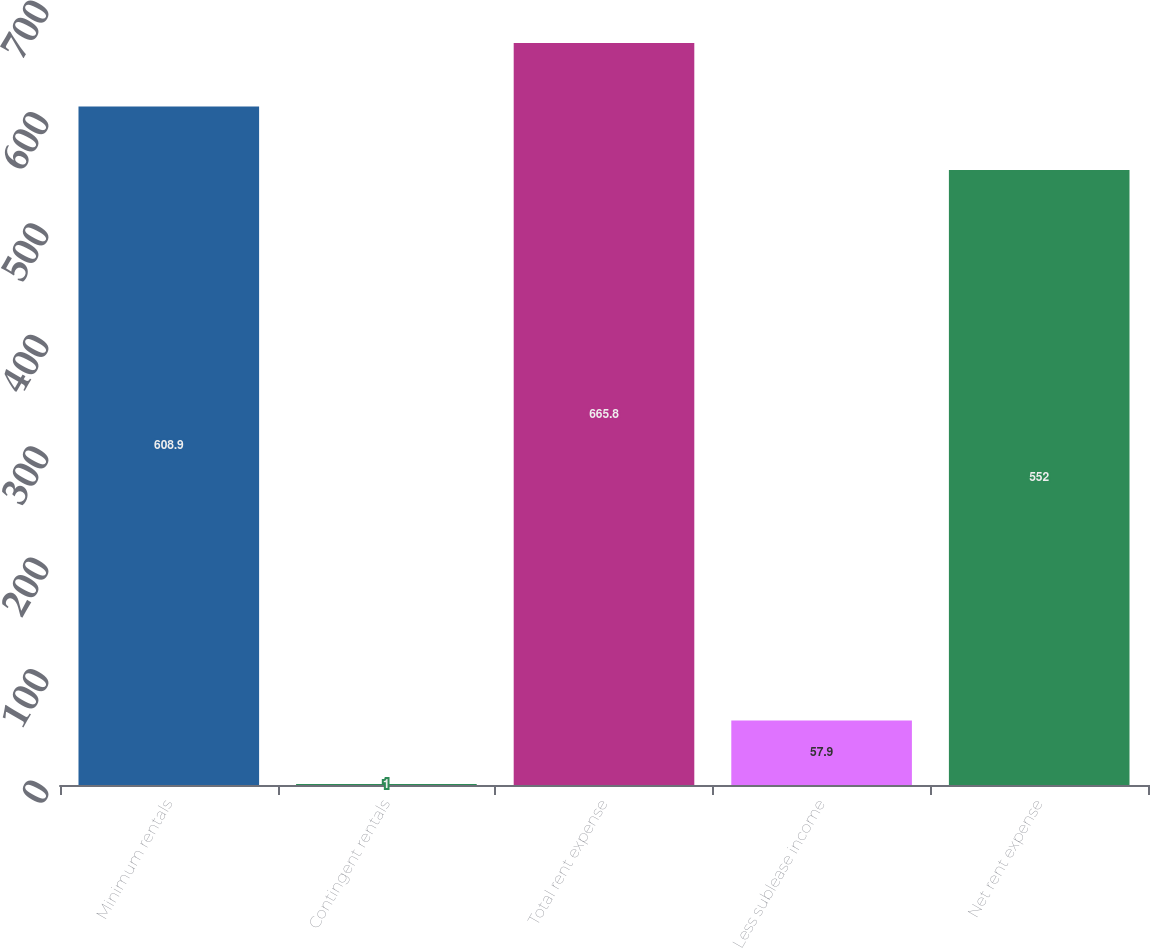Convert chart to OTSL. <chart><loc_0><loc_0><loc_500><loc_500><bar_chart><fcel>Minimum rentals<fcel>Contingent rentals<fcel>Total rent expense<fcel>Less sublease income<fcel>Net rent expense<nl><fcel>608.9<fcel>1<fcel>665.8<fcel>57.9<fcel>552<nl></chart> 